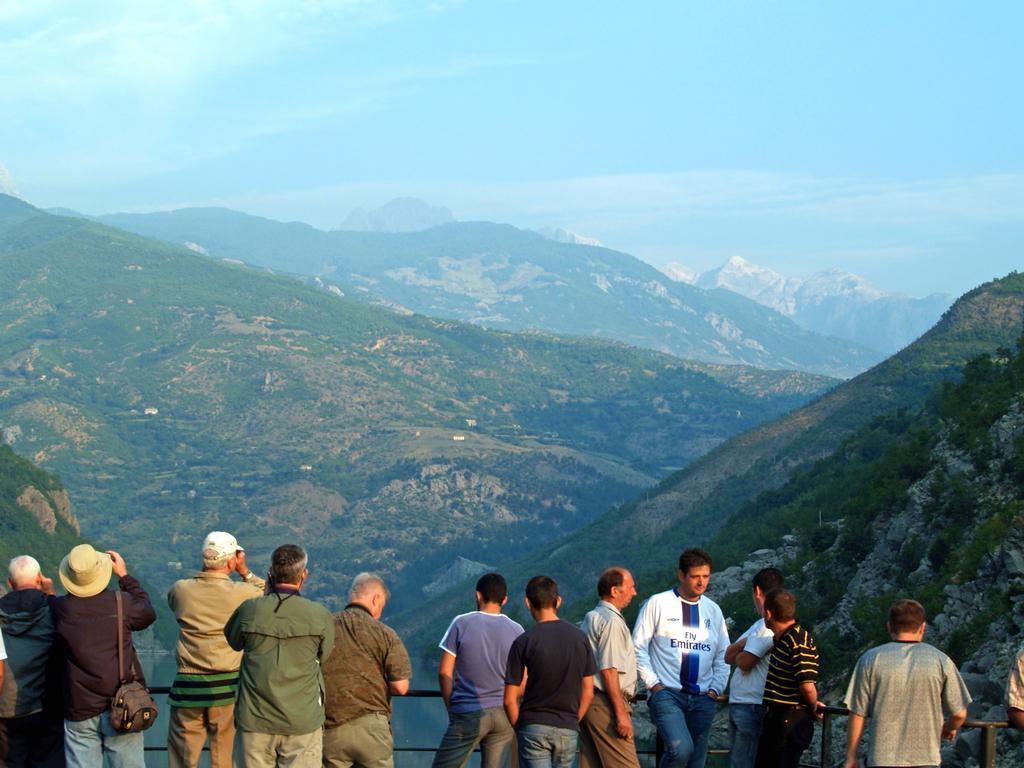Could you give a brief overview of what you see in this image? In this image, we can see so many mountains. Top of the image, there is a sky. At the bottom, we can see a group of people are standing near the rod fencing. On the left side, we can see two people are wearing cap, hat and bag. 